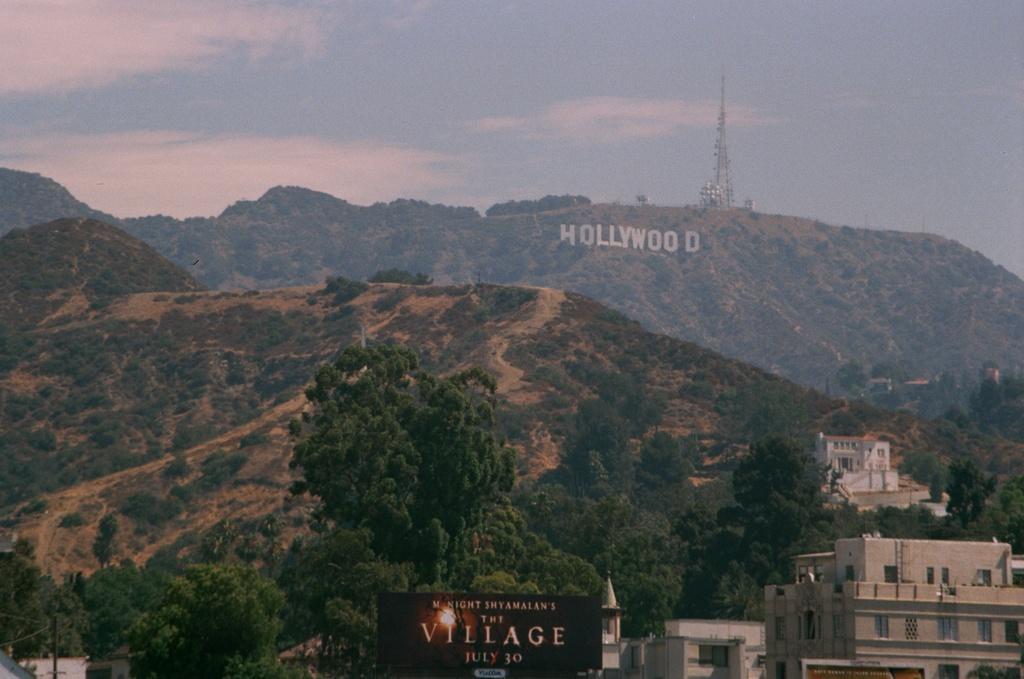In one or two sentences, can you explain what this image depicts? In the center of the image we can see hills. On the right there are buildings. At the bottom there is a board. In the background there is a mobile tower and sky. 